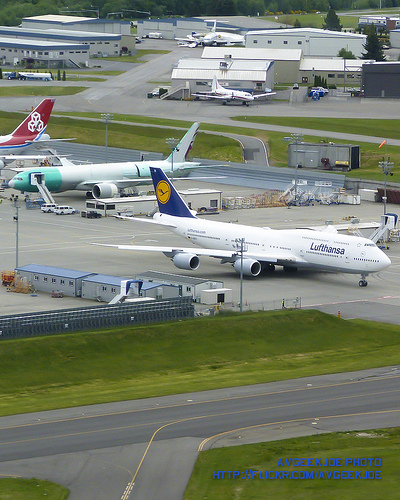<image>
Can you confirm if the car is next to the airplane? No. The car is not positioned next to the airplane. They are located in different areas of the scene. Where is the airplane in relation to the airplane? Is it under the airplane? No. The airplane is not positioned under the airplane. The vertical relationship between these objects is different. 